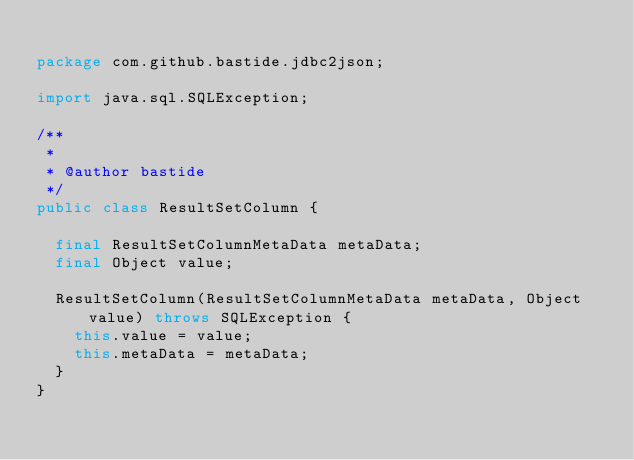<code> <loc_0><loc_0><loc_500><loc_500><_Java_>
package com.github.bastide.jdbc2json;

import java.sql.SQLException;

/**
 *
 * @author bastide
 */
public class ResultSetColumn {

	final ResultSetColumnMetaData metaData;
	final Object value;

	ResultSetColumn(ResultSetColumnMetaData metaData, Object value) throws SQLException {
		this.value = value;
		this.metaData = metaData;
	}
}</code> 